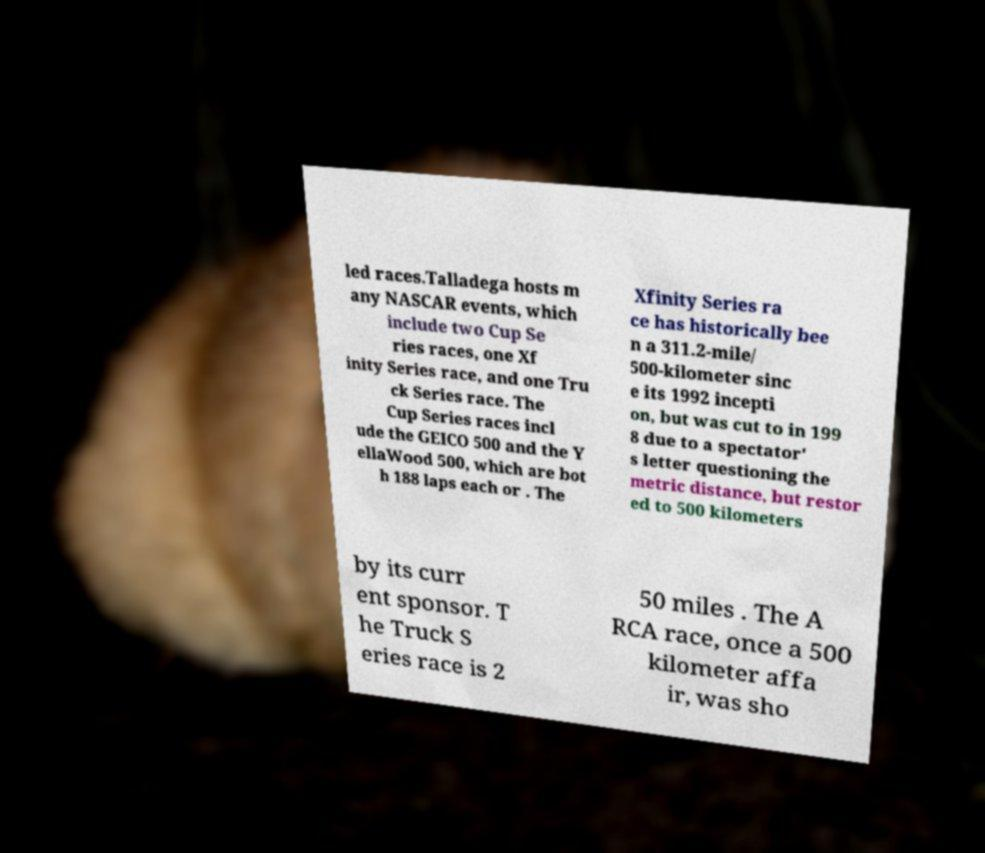Can you read and provide the text displayed in the image?This photo seems to have some interesting text. Can you extract and type it out for me? led races.Talladega hosts m any NASCAR events, which include two Cup Se ries races, one Xf inity Series race, and one Tru ck Series race. The Cup Series races incl ude the GEICO 500 and the Y ellaWood 500, which are bot h 188 laps each or . The Xfinity Series ra ce has historically bee n a 311.2-mile/ 500-kilometer sinc e its 1992 incepti on, but was cut to in 199 8 due to a spectator' s letter questioning the metric distance, but restor ed to 500 kilometers by its curr ent sponsor. T he Truck S eries race is 2 50 miles . The A RCA race, once a 500 kilometer affa ir, was sho 